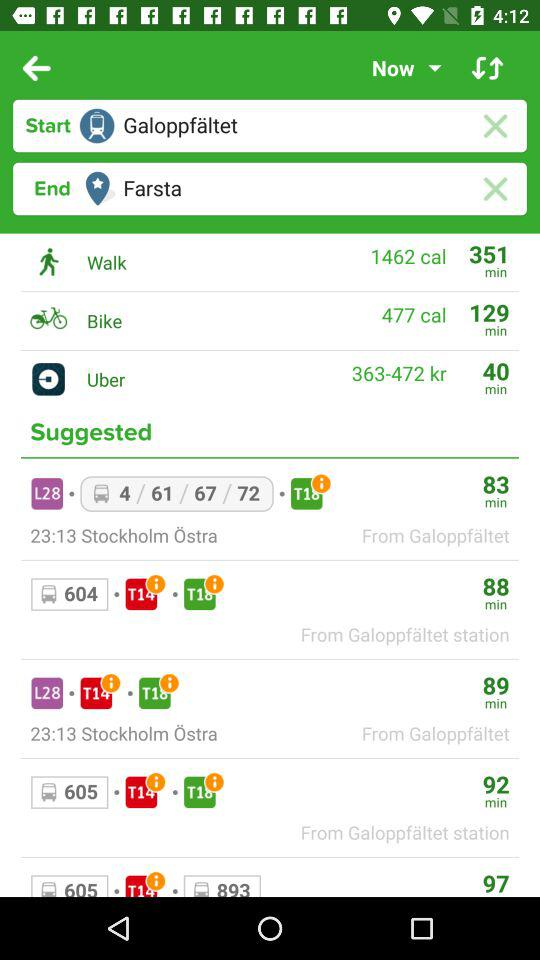How long will it take to reach Stockholm Ostra?
When the provided information is insufficient, respond with <no answer>. <no answer> 